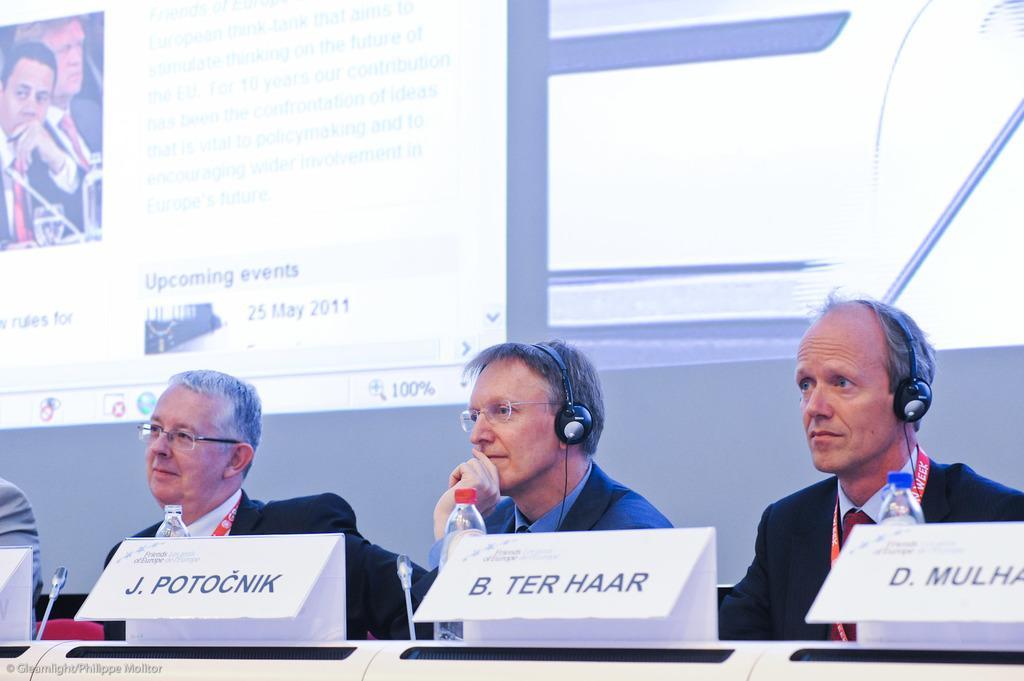Please provide a concise description of this image. In this image we can see group of people are sitting, they are wearing the headphones, in front there is a table, and there are microphones, name plates, water bottle on it, at the back there is a screen and something written on it. 